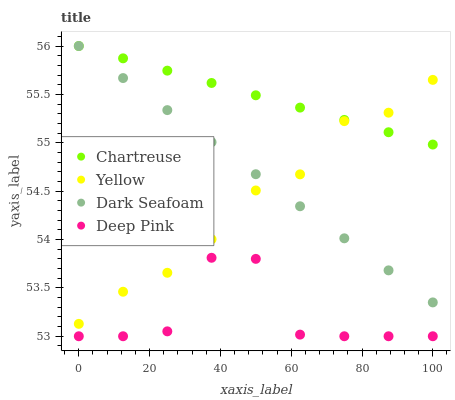Does Deep Pink have the minimum area under the curve?
Answer yes or no. Yes. Does Chartreuse have the maximum area under the curve?
Answer yes or no. Yes. Does Dark Seafoam have the minimum area under the curve?
Answer yes or no. No. Does Dark Seafoam have the maximum area under the curve?
Answer yes or no. No. Is Dark Seafoam the smoothest?
Answer yes or no. Yes. Is Deep Pink the roughest?
Answer yes or no. Yes. Is Deep Pink the smoothest?
Answer yes or no. No. Is Dark Seafoam the roughest?
Answer yes or no. No. Does Deep Pink have the lowest value?
Answer yes or no. Yes. Does Dark Seafoam have the lowest value?
Answer yes or no. No. Does Dark Seafoam have the highest value?
Answer yes or no. Yes. Does Deep Pink have the highest value?
Answer yes or no. No. Is Deep Pink less than Dark Seafoam?
Answer yes or no. Yes. Is Dark Seafoam greater than Deep Pink?
Answer yes or no. Yes. Does Yellow intersect Dark Seafoam?
Answer yes or no. Yes. Is Yellow less than Dark Seafoam?
Answer yes or no. No. Is Yellow greater than Dark Seafoam?
Answer yes or no. No. Does Deep Pink intersect Dark Seafoam?
Answer yes or no. No. 